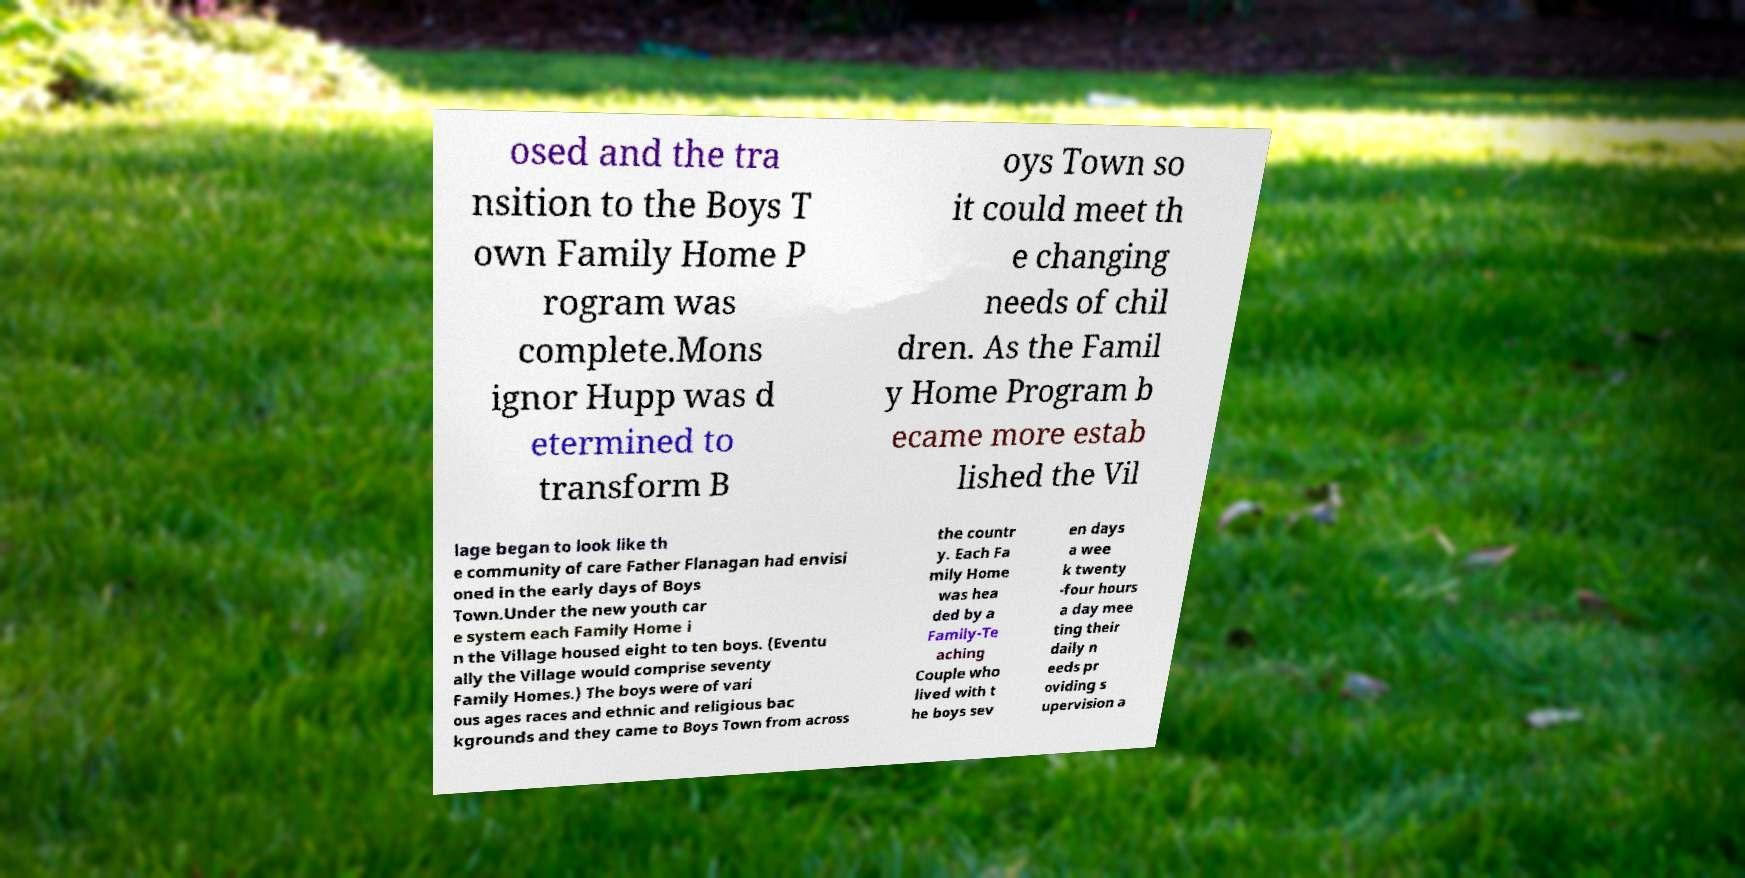There's text embedded in this image that I need extracted. Can you transcribe it verbatim? osed and the tra nsition to the Boys T own Family Home P rogram was complete.Mons ignor Hupp was d etermined to transform B oys Town so it could meet th e changing needs of chil dren. As the Famil y Home Program b ecame more estab lished the Vil lage began to look like th e community of care Father Flanagan had envisi oned in the early days of Boys Town.Under the new youth car e system each Family Home i n the Village housed eight to ten boys. (Eventu ally the Village would comprise seventy Family Homes.) The boys were of vari ous ages races and ethnic and religious bac kgrounds and they came to Boys Town from across the countr y. Each Fa mily Home was hea ded by a Family-Te aching Couple who lived with t he boys sev en days a wee k twenty -four hours a day mee ting their daily n eeds pr oviding s upervision a 